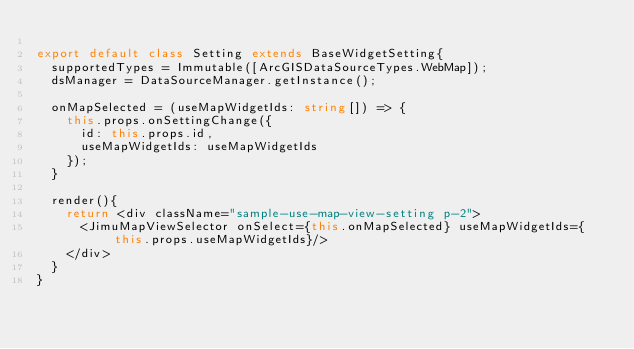<code> <loc_0><loc_0><loc_500><loc_500><_TypeScript_>
export default class Setting extends BaseWidgetSetting{
  supportedTypes = Immutable([ArcGISDataSourceTypes.WebMap]);
  dsManager = DataSourceManager.getInstance();

  onMapSelected = (useMapWidgetIds: string[]) => {
    this.props.onSettingChange({
      id: this.props.id,
      useMapWidgetIds: useMapWidgetIds
    });
  }

  render(){
    return <div className="sample-use-map-view-setting p-2">
      <JimuMapViewSelector onSelect={this.onMapSelected} useMapWidgetIds={this.props.useMapWidgetIds}/>
    </div>
  }
}</code> 